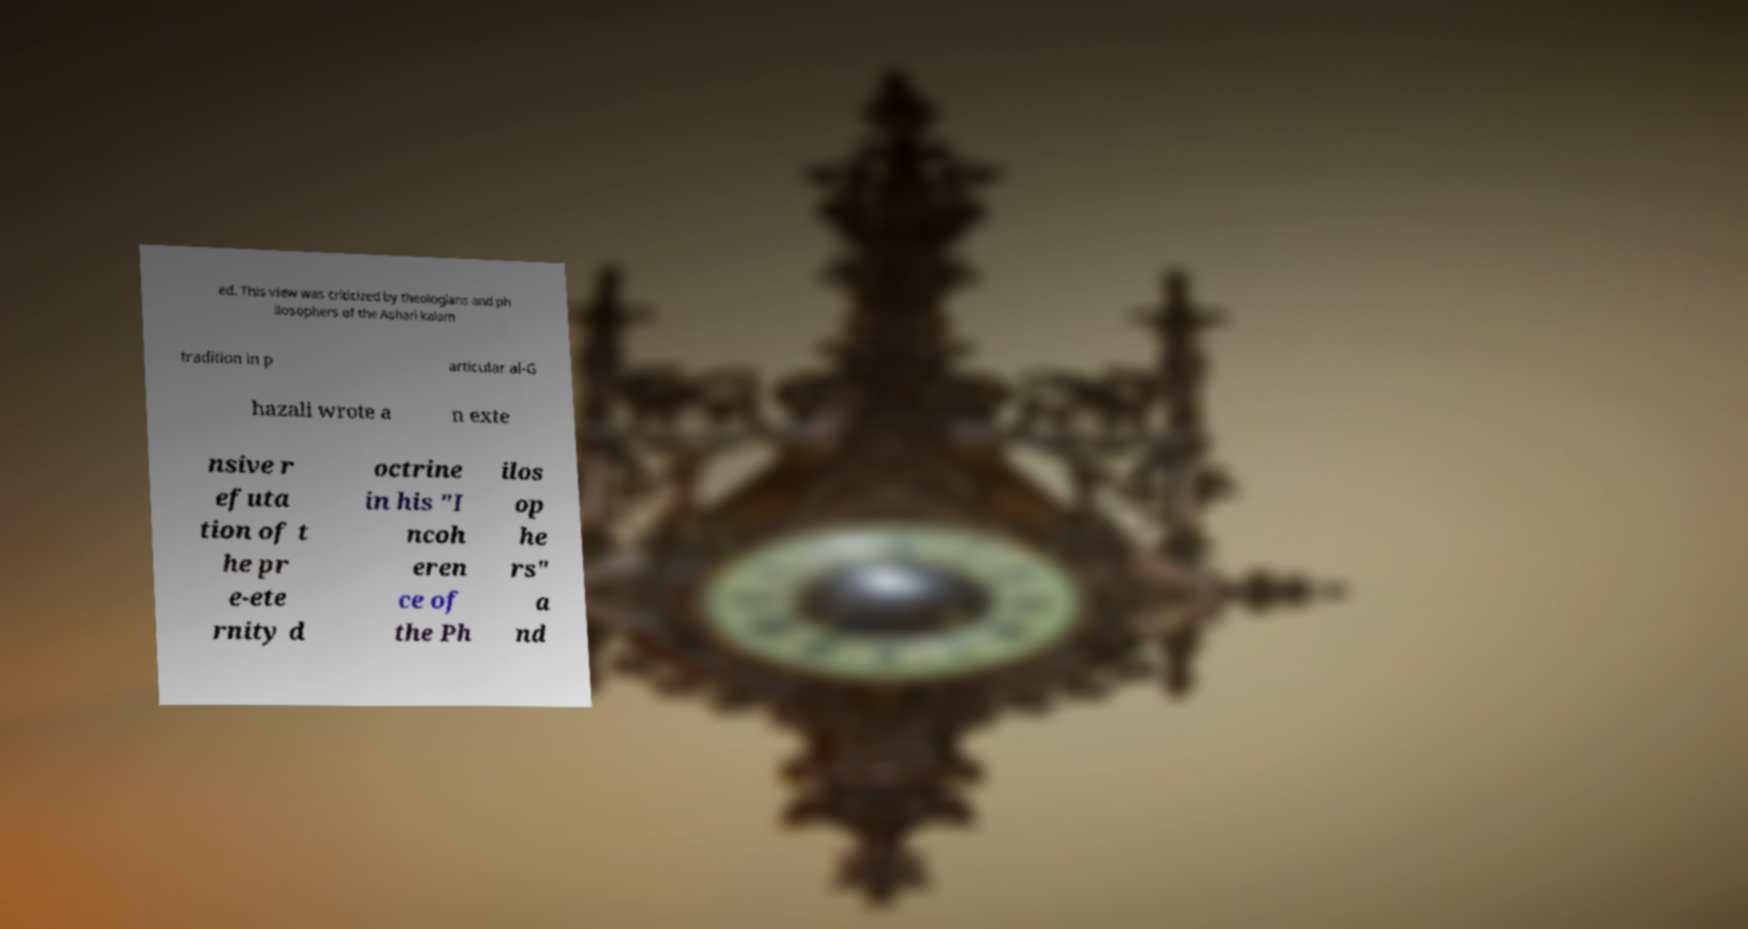For documentation purposes, I need the text within this image transcribed. Could you provide that? ed. This view was criticized by theologians and ph ilosophers of the Ashari kalam tradition in p articular al-G hazali wrote a n exte nsive r efuta tion of t he pr e-ete rnity d octrine in his "I ncoh eren ce of the Ph ilos op he rs" a nd 